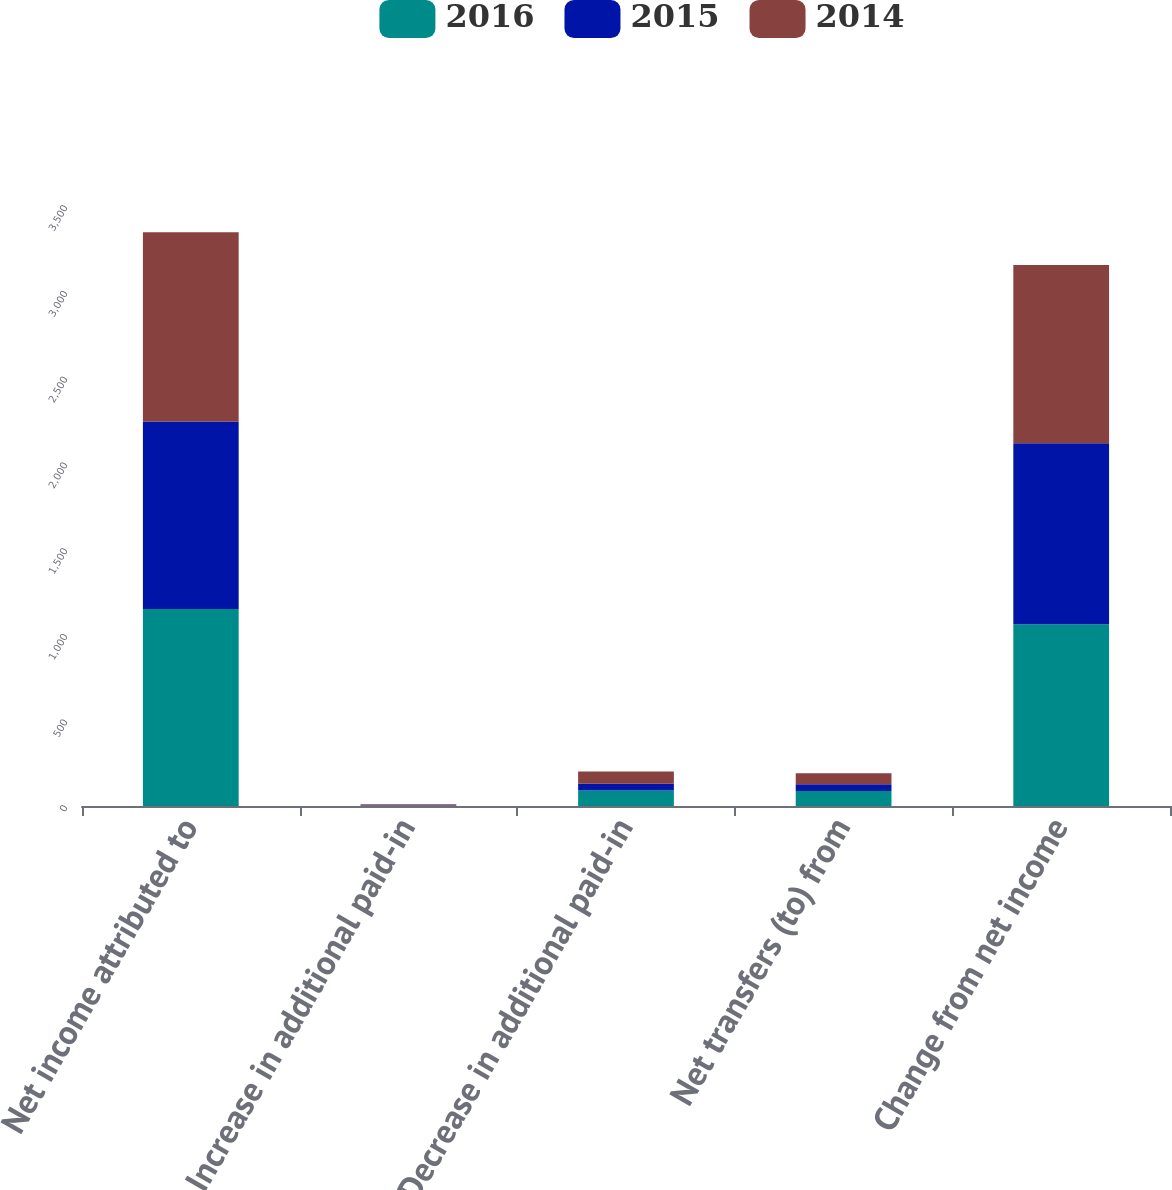Convert chart. <chart><loc_0><loc_0><loc_500><loc_500><stacked_bar_chart><ecel><fcel>Net income attributed to<fcel>Increase in additional paid-in<fcel>Decrease in additional paid-in<fcel>Net transfers (to) from<fcel>Change from net income<nl><fcel>2016<fcel>1148.6<fcel>2<fcel>89.7<fcel>87.7<fcel>1060.9<nl><fcel>2015<fcel>1093.9<fcel>1.7<fcel>40.5<fcel>38.8<fcel>1055.1<nl><fcel>2014<fcel>1104<fcel>6.3<fcel>70.8<fcel>64.5<fcel>1039.5<nl></chart> 